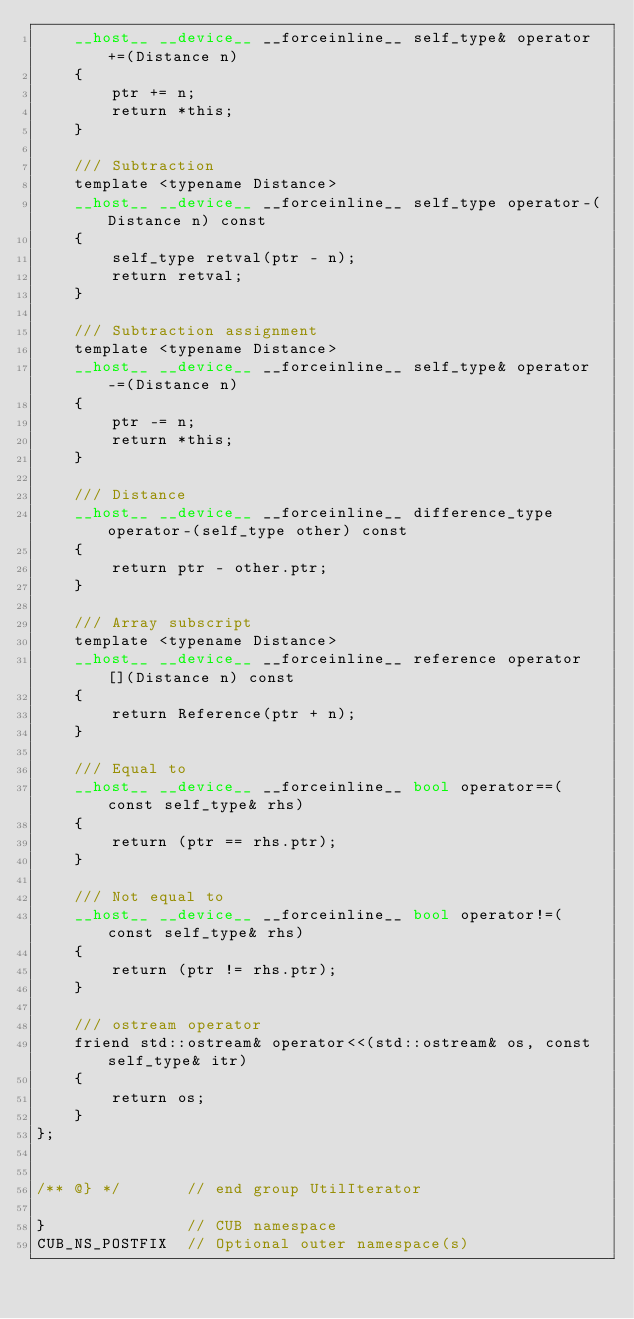Convert code to text. <code><loc_0><loc_0><loc_500><loc_500><_Cuda_>    __host__ __device__ __forceinline__ self_type& operator+=(Distance n)
    {
        ptr += n;
        return *this;
    }

    /// Subtraction
    template <typename Distance>
    __host__ __device__ __forceinline__ self_type operator-(Distance n) const
    {
        self_type retval(ptr - n);
        return retval;
    }

    /// Subtraction assignment
    template <typename Distance>
    __host__ __device__ __forceinline__ self_type& operator-=(Distance n)
    {
        ptr -= n;
        return *this;
    }

    /// Distance
    __host__ __device__ __forceinline__ difference_type operator-(self_type other) const
    {
        return ptr - other.ptr;
    }

    /// Array subscript
    template <typename Distance>
    __host__ __device__ __forceinline__ reference operator[](Distance n) const
    {
        return Reference(ptr + n);
    }

    /// Equal to
    __host__ __device__ __forceinline__ bool operator==(const self_type& rhs)
    {
        return (ptr == rhs.ptr);
    }

    /// Not equal to
    __host__ __device__ __forceinline__ bool operator!=(const self_type& rhs)
    {
        return (ptr != rhs.ptr);
    }

    /// ostream operator
    friend std::ostream& operator<<(std::ostream& os, const self_type& itr)
    {
        return os;
    }
};


/** @} */       // end group UtilIterator

}               // CUB namespace
CUB_NS_POSTFIX  // Optional outer namespace(s)
</code> 